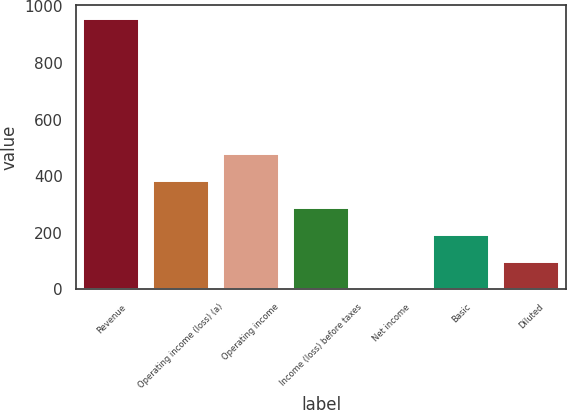<chart> <loc_0><loc_0><loc_500><loc_500><bar_chart><fcel>Revenue<fcel>Operating income (loss) (a)<fcel>Operating income<fcel>Income (loss) before taxes<fcel>Net income<fcel>Basic<fcel>Diluted<nl><fcel>955.6<fcel>382.54<fcel>478.05<fcel>287.03<fcel>0.5<fcel>191.52<fcel>96.01<nl></chart> 